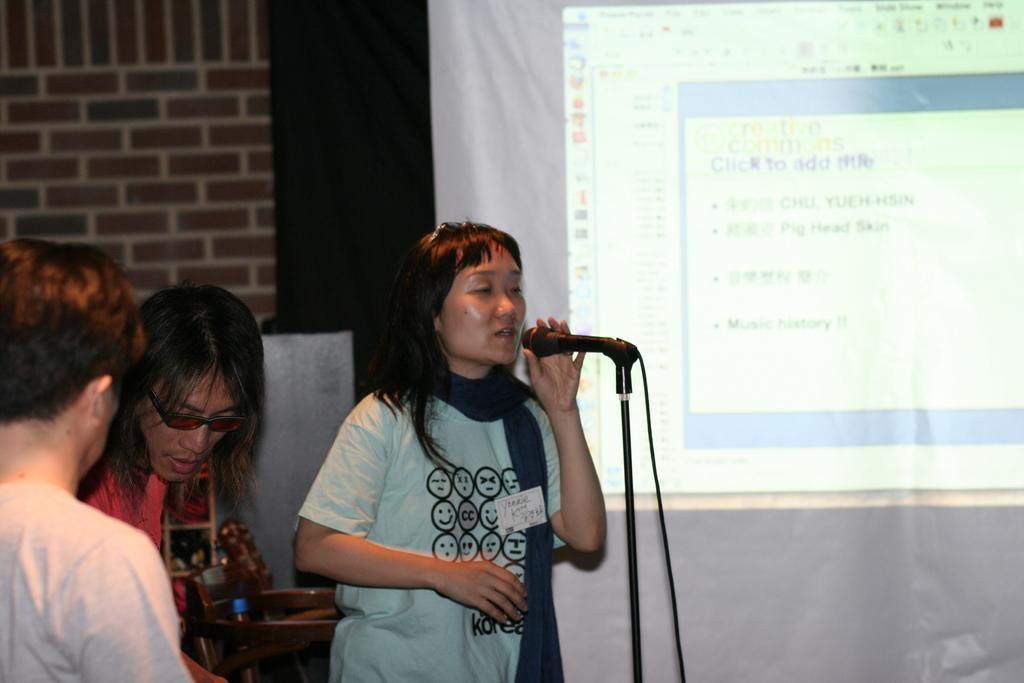Describe this image in one or two sentences. This is the picture taken in a room. The woman in blue t shirt holding a microphone with stand. On the left side of the women there are persons standing on the floor. On the right side of the women there is a projector screen. Background of the woman is a wall. 